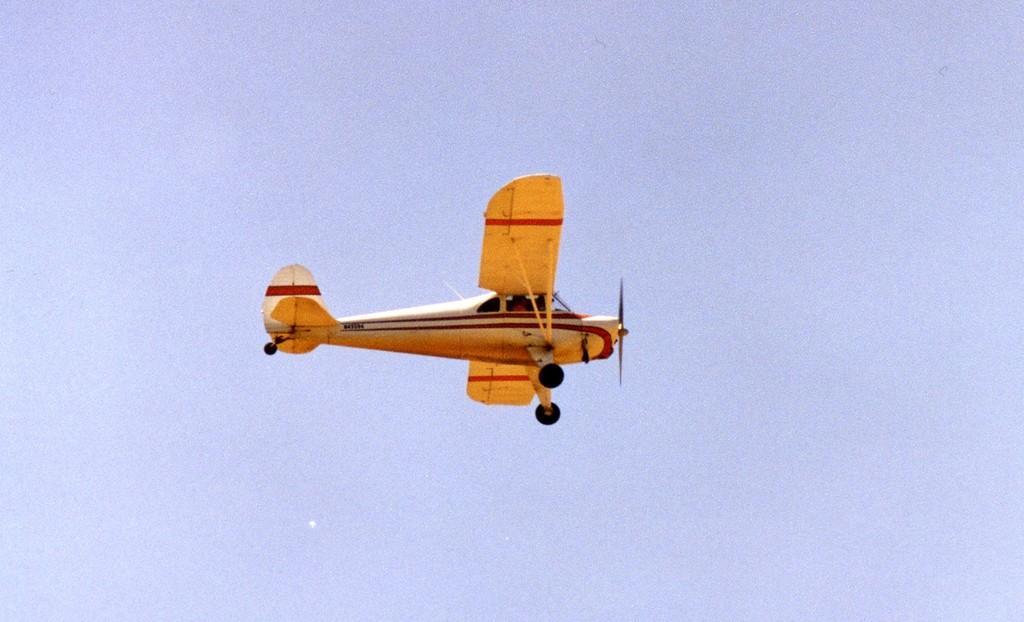Describe this image in one or two sentences. In the picture I can see an airplane is flying in the air. The airplane is yellow in color. In the background I can see the sky. 